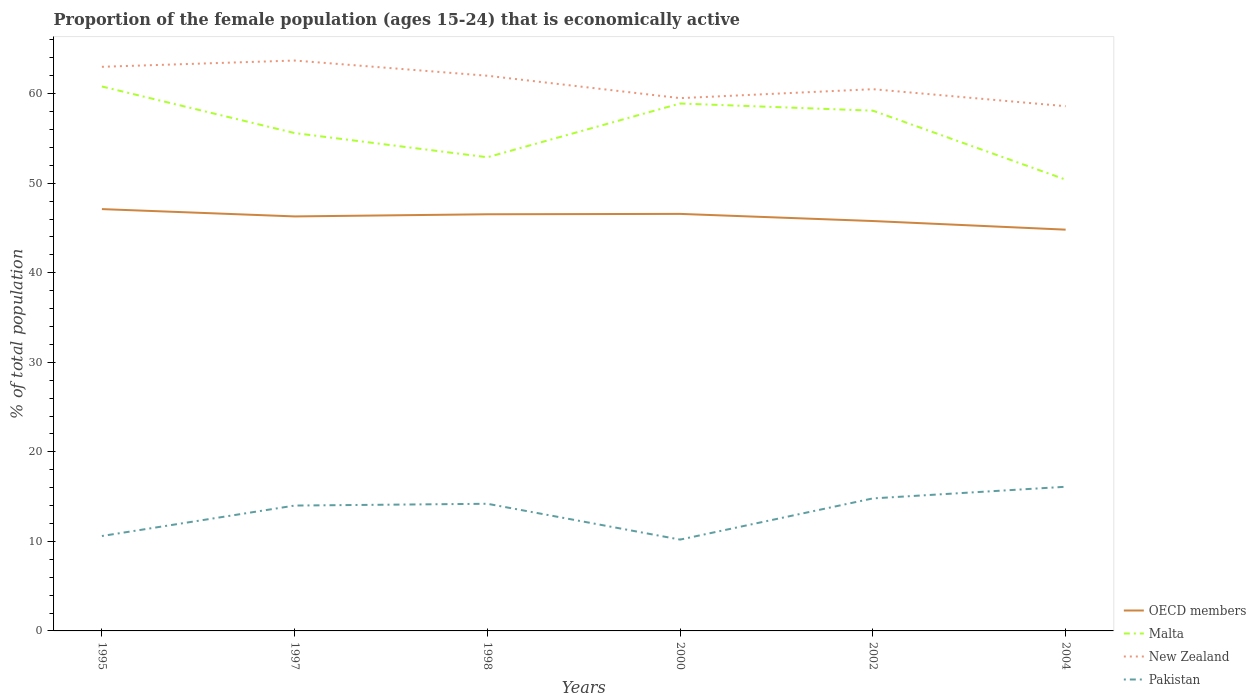Is the number of lines equal to the number of legend labels?
Offer a very short reply. Yes. Across all years, what is the maximum proportion of the female population that is economically active in Malta?
Your response must be concise. 50.4. In which year was the proportion of the female population that is economically active in OECD members maximum?
Your answer should be compact. 2004. What is the total proportion of the female population that is economically active in New Zealand in the graph?
Keep it short and to the point. 0.9. What is the difference between the highest and the second highest proportion of the female population that is economically active in OECD members?
Provide a succinct answer. 2.3. Is the proportion of the female population that is economically active in Malta strictly greater than the proportion of the female population that is economically active in OECD members over the years?
Your answer should be compact. No. How many lines are there?
Make the answer very short. 4. Are the values on the major ticks of Y-axis written in scientific E-notation?
Offer a very short reply. No. Does the graph contain any zero values?
Give a very brief answer. No. Where does the legend appear in the graph?
Keep it short and to the point. Bottom right. How many legend labels are there?
Give a very brief answer. 4. How are the legend labels stacked?
Your answer should be compact. Vertical. What is the title of the graph?
Make the answer very short. Proportion of the female population (ages 15-24) that is economically active. What is the label or title of the X-axis?
Offer a very short reply. Years. What is the label or title of the Y-axis?
Provide a short and direct response. % of total population. What is the % of total population in OECD members in 1995?
Your response must be concise. 47.11. What is the % of total population in Malta in 1995?
Your response must be concise. 60.8. What is the % of total population of Pakistan in 1995?
Give a very brief answer. 10.6. What is the % of total population in OECD members in 1997?
Give a very brief answer. 46.29. What is the % of total population in Malta in 1997?
Offer a very short reply. 55.6. What is the % of total population in New Zealand in 1997?
Keep it short and to the point. 63.7. What is the % of total population in Pakistan in 1997?
Make the answer very short. 14. What is the % of total population of OECD members in 1998?
Your answer should be very brief. 46.53. What is the % of total population of Malta in 1998?
Ensure brevity in your answer.  52.9. What is the % of total population in Pakistan in 1998?
Offer a very short reply. 14.2. What is the % of total population in OECD members in 2000?
Give a very brief answer. 46.57. What is the % of total population in Malta in 2000?
Offer a terse response. 58.9. What is the % of total population of New Zealand in 2000?
Your answer should be very brief. 59.5. What is the % of total population of Pakistan in 2000?
Offer a terse response. 10.2. What is the % of total population in OECD members in 2002?
Provide a succinct answer. 45.77. What is the % of total population in Malta in 2002?
Ensure brevity in your answer.  58.1. What is the % of total population of New Zealand in 2002?
Your answer should be compact. 60.5. What is the % of total population of Pakistan in 2002?
Make the answer very short. 14.8. What is the % of total population in OECD members in 2004?
Keep it short and to the point. 44.81. What is the % of total population in Malta in 2004?
Your response must be concise. 50.4. What is the % of total population in New Zealand in 2004?
Offer a very short reply. 58.6. What is the % of total population of Pakistan in 2004?
Make the answer very short. 16.1. Across all years, what is the maximum % of total population in OECD members?
Offer a terse response. 47.11. Across all years, what is the maximum % of total population in Malta?
Give a very brief answer. 60.8. Across all years, what is the maximum % of total population in New Zealand?
Make the answer very short. 63.7. Across all years, what is the maximum % of total population in Pakistan?
Provide a short and direct response. 16.1. Across all years, what is the minimum % of total population of OECD members?
Keep it short and to the point. 44.81. Across all years, what is the minimum % of total population in Malta?
Give a very brief answer. 50.4. Across all years, what is the minimum % of total population of New Zealand?
Provide a short and direct response. 58.6. Across all years, what is the minimum % of total population of Pakistan?
Provide a succinct answer. 10.2. What is the total % of total population in OECD members in the graph?
Offer a very short reply. 277.09. What is the total % of total population of Malta in the graph?
Make the answer very short. 336.7. What is the total % of total population in New Zealand in the graph?
Your answer should be very brief. 367.3. What is the total % of total population in Pakistan in the graph?
Provide a short and direct response. 79.9. What is the difference between the % of total population of OECD members in 1995 and that in 1997?
Give a very brief answer. 0.82. What is the difference between the % of total population of Malta in 1995 and that in 1997?
Ensure brevity in your answer.  5.2. What is the difference between the % of total population of OECD members in 1995 and that in 1998?
Your response must be concise. 0.58. What is the difference between the % of total population of Malta in 1995 and that in 1998?
Offer a terse response. 7.9. What is the difference between the % of total population in New Zealand in 1995 and that in 1998?
Ensure brevity in your answer.  1. What is the difference between the % of total population in OECD members in 1995 and that in 2000?
Your answer should be compact. 0.53. What is the difference between the % of total population of New Zealand in 1995 and that in 2000?
Your response must be concise. 3.5. What is the difference between the % of total population of Pakistan in 1995 and that in 2000?
Ensure brevity in your answer.  0.4. What is the difference between the % of total population of OECD members in 1995 and that in 2002?
Offer a very short reply. 1.33. What is the difference between the % of total population in OECD members in 1995 and that in 2004?
Ensure brevity in your answer.  2.3. What is the difference between the % of total population in Malta in 1995 and that in 2004?
Provide a short and direct response. 10.4. What is the difference between the % of total population of OECD members in 1997 and that in 1998?
Make the answer very short. -0.24. What is the difference between the % of total population in Malta in 1997 and that in 1998?
Ensure brevity in your answer.  2.7. What is the difference between the % of total population of Pakistan in 1997 and that in 1998?
Keep it short and to the point. -0.2. What is the difference between the % of total population of OECD members in 1997 and that in 2000?
Offer a very short reply. -0.28. What is the difference between the % of total population of OECD members in 1997 and that in 2002?
Give a very brief answer. 0.51. What is the difference between the % of total population in Malta in 1997 and that in 2002?
Provide a succinct answer. -2.5. What is the difference between the % of total population in OECD members in 1997 and that in 2004?
Provide a short and direct response. 1.48. What is the difference between the % of total population of Pakistan in 1997 and that in 2004?
Your response must be concise. -2.1. What is the difference between the % of total population of OECD members in 1998 and that in 2000?
Give a very brief answer. -0.04. What is the difference between the % of total population in New Zealand in 1998 and that in 2000?
Provide a short and direct response. 2.5. What is the difference between the % of total population of OECD members in 1998 and that in 2002?
Keep it short and to the point. 0.76. What is the difference between the % of total population of Malta in 1998 and that in 2002?
Keep it short and to the point. -5.2. What is the difference between the % of total population of New Zealand in 1998 and that in 2002?
Provide a succinct answer. 1.5. What is the difference between the % of total population of Pakistan in 1998 and that in 2002?
Provide a succinct answer. -0.6. What is the difference between the % of total population of OECD members in 1998 and that in 2004?
Your answer should be compact. 1.72. What is the difference between the % of total population of Malta in 1998 and that in 2004?
Provide a succinct answer. 2.5. What is the difference between the % of total population of New Zealand in 1998 and that in 2004?
Your answer should be very brief. 3.4. What is the difference between the % of total population of OECD members in 2000 and that in 2002?
Give a very brief answer. 0.8. What is the difference between the % of total population of Malta in 2000 and that in 2002?
Provide a succinct answer. 0.8. What is the difference between the % of total population in New Zealand in 2000 and that in 2002?
Offer a very short reply. -1. What is the difference between the % of total population of Pakistan in 2000 and that in 2002?
Your answer should be compact. -4.6. What is the difference between the % of total population in OECD members in 2000 and that in 2004?
Provide a succinct answer. 1.76. What is the difference between the % of total population in Pakistan in 2000 and that in 2004?
Provide a succinct answer. -5.9. What is the difference between the % of total population in OECD members in 2002 and that in 2004?
Provide a succinct answer. 0.96. What is the difference between the % of total population in Malta in 2002 and that in 2004?
Your answer should be very brief. 7.7. What is the difference between the % of total population of Pakistan in 2002 and that in 2004?
Keep it short and to the point. -1.3. What is the difference between the % of total population in OECD members in 1995 and the % of total population in Malta in 1997?
Provide a succinct answer. -8.49. What is the difference between the % of total population of OECD members in 1995 and the % of total population of New Zealand in 1997?
Offer a very short reply. -16.59. What is the difference between the % of total population of OECD members in 1995 and the % of total population of Pakistan in 1997?
Your answer should be very brief. 33.11. What is the difference between the % of total population in Malta in 1995 and the % of total population in New Zealand in 1997?
Offer a terse response. -2.9. What is the difference between the % of total population of Malta in 1995 and the % of total population of Pakistan in 1997?
Your answer should be compact. 46.8. What is the difference between the % of total population of OECD members in 1995 and the % of total population of Malta in 1998?
Offer a terse response. -5.79. What is the difference between the % of total population in OECD members in 1995 and the % of total population in New Zealand in 1998?
Offer a very short reply. -14.89. What is the difference between the % of total population of OECD members in 1995 and the % of total population of Pakistan in 1998?
Your answer should be compact. 32.91. What is the difference between the % of total population of Malta in 1995 and the % of total population of Pakistan in 1998?
Offer a very short reply. 46.6. What is the difference between the % of total population of New Zealand in 1995 and the % of total population of Pakistan in 1998?
Your answer should be compact. 48.8. What is the difference between the % of total population in OECD members in 1995 and the % of total population in Malta in 2000?
Provide a short and direct response. -11.79. What is the difference between the % of total population in OECD members in 1995 and the % of total population in New Zealand in 2000?
Ensure brevity in your answer.  -12.39. What is the difference between the % of total population of OECD members in 1995 and the % of total population of Pakistan in 2000?
Provide a succinct answer. 36.91. What is the difference between the % of total population of Malta in 1995 and the % of total population of Pakistan in 2000?
Keep it short and to the point. 50.6. What is the difference between the % of total population in New Zealand in 1995 and the % of total population in Pakistan in 2000?
Provide a succinct answer. 52.8. What is the difference between the % of total population in OECD members in 1995 and the % of total population in Malta in 2002?
Provide a short and direct response. -10.99. What is the difference between the % of total population of OECD members in 1995 and the % of total population of New Zealand in 2002?
Give a very brief answer. -13.39. What is the difference between the % of total population in OECD members in 1995 and the % of total population in Pakistan in 2002?
Give a very brief answer. 32.31. What is the difference between the % of total population in Malta in 1995 and the % of total population in New Zealand in 2002?
Offer a terse response. 0.3. What is the difference between the % of total population in New Zealand in 1995 and the % of total population in Pakistan in 2002?
Make the answer very short. 48.2. What is the difference between the % of total population of OECD members in 1995 and the % of total population of Malta in 2004?
Ensure brevity in your answer.  -3.29. What is the difference between the % of total population in OECD members in 1995 and the % of total population in New Zealand in 2004?
Your answer should be very brief. -11.49. What is the difference between the % of total population in OECD members in 1995 and the % of total population in Pakistan in 2004?
Make the answer very short. 31.01. What is the difference between the % of total population in Malta in 1995 and the % of total population in New Zealand in 2004?
Ensure brevity in your answer.  2.2. What is the difference between the % of total population of Malta in 1995 and the % of total population of Pakistan in 2004?
Your answer should be compact. 44.7. What is the difference between the % of total population in New Zealand in 1995 and the % of total population in Pakistan in 2004?
Your response must be concise. 46.9. What is the difference between the % of total population in OECD members in 1997 and the % of total population in Malta in 1998?
Ensure brevity in your answer.  -6.61. What is the difference between the % of total population in OECD members in 1997 and the % of total population in New Zealand in 1998?
Offer a very short reply. -15.71. What is the difference between the % of total population of OECD members in 1997 and the % of total population of Pakistan in 1998?
Keep it short and to the point. 32.09. What is the difference between the % of total population in Malta in 1997 and the % of total population in Pakistan in 1998?
Make the answer very short. 41.4. What is the difference between the % of total population in New Zealand in 1997 and the % of total population in Pakistan in 1998?
Offer a terse response. 49.5. What is the difference between the % of total population in OECD members in 1997 and the % of total population in Malta in 2000?
Ensure brevity in your answer.  -12.61. What is the difference between the % of total population of OECD members in 1997 and the % of total population of New Zealand in 2000?
Your response must be concise. -13.21. What is the difference between the % of total population in OECD members in 1997 and the % of total population in Pakistan in 2000?
Your answer should be very brief. 36.09. What is the difference between the % of total population of Malta in 1997 and the % of total population of Pakistan in 2000?
Provide a short and direct response. 45.4. What is the difference between the % of total population in New Zealand in 1997 and the % of total population in Pakistan in 2000?
Provide a succinct answer. 53.5. What is the difference between the % of total population in OECD members in 1997 and the % of total population in Malta in 2002?
Provide a succinct answer. -11.81. What is the difference between the % of total population in OECD members in 1997 and the % of total population in New Zealand in 2002?
Your response must be concise. -14.21. What is the difference between the % of total population in OECD members in 1997 and the % of total population in Pakistan in 2002?
Offer a very short reply. 31.49. What is the difference between the % of total population of Malta in 1997 and the % of total population of Pakistan in 2002?
Offer a terse response. 40.8. What is the difference between the % of total population of New Zealand in 1997 and the % of total population of Pakistan in 2002?
Provide a short and direct response. 48.9. What is the difference between the % of total population in OECD members in 1997 and the % of total population in Malta in 2004?
Offer a terse response. -4.11. What is the difference between the % of total population in OECD members in 1997 and the % of total population in New Zealand in 2004?
Offer a very short reply. -12.31. What is the difference between the % of total population in OECD members in 1997 and the % of total population in Pakistan in 2004?
Give a very brief answer. 30.19. What is the difference between the % of total population of Malta in 1997 and the % of total population of Pakistan in 2004?
Your answer should be compact. 39.5. What is the difference between the % of total population of New Zealand in 1997 and the % of total population of Pakistan in 2004?
Offer a terse response. 47.6. What is the difference between the % of total population of OECD members in 1998 and the % of total population of Malta in 2000?
Your answer should be compact. -12.37. What is the difference between the % of total population in OECD members in 1998 and the % of total population in New Zealand in 2000?
Your response must be concise. -12.97. What is the difference between the % of total population of OECD members in 1998 and the % of total population of Pakistan in 2000?
Ensure brevity in your answer.  36.33. What is the difference between the % of total population of Malta in 1998 and the % of total population of New Zealand in 2000?
Ensure brevity in your answer.  -6.6. What is the difference between the % of total population in Malta in 1998 and the % of total population in Pakistan in 2000?
Provide a succinct answer. 42.7. What is the difference between the % of total population in New Zealand in 1998 and the % of total population in Pakistan in 2000?
Provide a succinct answer. 51.8. What is the difference between the % of total population of OECD members in 1998 and the % of total population of Malta in 2002?
Make the answer very short. -11.57. What is the difference between the % of total population in OECD members in 1998 and the % of total population in New Zealand in 2002?
Provide a succinct answer. -13.97. What is the difference between the % of total population of OECD members in 1998 and the % of total population of Pakistan in 2002?
Your answer should be compact. 31.73. What is the difference between the % of total population in Malta in 1998 and the % of total population in Pakistan in 2002?
Provide a short and direct response. 38.1. What is the difference between the % of total population in New Zealand in 1998 and the % of total population in Pakistan in 2002?
Make the answer very short. 47.2. What is the difference between the % of total population of OECD members in 1998 and the % of total population of Malta in 2004?
Ensure brevity in your answer.  -3.87. What is the difference between the % of total population of OECD members in 1998 and the % of total population of New Zealand in 2004?
Offer a very short reply. -12.07. What is the difference between the % of total population in OECD members in 1998 and the % of total population in Pakistan in 2004?
Keep it short and to the point. 30.43. What is the difference between the % of total population in Malta in 1998 and the % of total population in Pakistan in 2004?
Provide a short and direct response. 36.8. What is the difference between the % of total population in New Zealand in 1998 and the % of total population in Pakistan in 2004?
Your answer should be very brief. 45.9. What is the difference between the % of total population in OECD members in 2000 and the % of total population in Malta in 2002?
Keep it short and to the point. -11.53. What is the difference between the % of total population in OECD members in 2000 and the % of total population in New Zealand in 2002?
Make the answer very short. -13.93. What is the difference between the % of total population in OECD members in 2000 and the % of total population in Pakistan in 2002?
Ensure brevity in your answer.  31.77. What is the difference between the % of total population of Malta in 2000 and the % of total population of Pakistan in 2002?
Keep it short and to the point. 44.1. What is the difference between the % of total population in New Zealand in 2000 and the % of total population in Pakistan in 2002?
Give a very brief answer. 44.7. What is the difference between the % of total population of OECD members in 2000 and the % of total population of Malta in 2004?
Offer a very short reply. -3.83. What is the difference between the % of total population of OECD members in 2000 and the % of total population of New Zealand in 2004?
Your answer should be compact. -12.03. What is the difference between the % of total population in OECD members in 2000 and the % of total population in Pakistan in 2004?
Offer a very short reply. 30.47. What is the difference between the % of total population of Malta in 2000 and the % of total population of Pakistan in 2004?
Your answer should be compact. 42.8. What is the difference between the % of total population in New Zealand in 2000 and the % of total population in Pakistan in 2004?
Offer a terse response. 43.4. What is the difference between the % of total population in OECD members in 2002 and the % of total population in Malta in 2004?
Offer a very short reply. -4.63. What is the difference between the % of total population in OECD members in 2002 and the % of total population in New Zealand in 2004?
Offer a terse response. -12.83. What is the difference between the % of total population of OECD members in 2002 and the % of total population of Pakistan in 2004?
Ensure brevity in your answer.  29.67. What is the difference between the % of total population in Malta in 2002 and the % of total population in Pakistan in 2004?
Your answer should be very brief. 42. What is the difference between the % of total population in New Zealand in 2002 and the % of total population in Pakistan in 2004?
Offer a very short reply. 44.4. What is the average % of total population of OECD members per year?
Offer a very short reply. 46.18. What is the average % of total population of Malta per year?
Make the answer very short. 56.12. What is the average % of total population in New Zealand per year?
Provide a succinct answer. 61.22. What is the average % of total population in Pakistan per year?
Provide a succinct answer. 13.32. In the year 1995, what is the difference between the % of total population of OECD members and % of total population of Malta?
Your answer should be compact. -13.69. In the year 1995, what is the difference between the % of total population of OECD members and % of total population of New Zealand?
Provide a succinct answer. -15.89. In the year 1995, what is the difference between the % of total population of OECD members and % of total population of Pakistan?
Your response must be concise. 36.51. In the year 1995, what is the difference between the % of total population in Malta and % of total population in Pakistan?
Your answer should be very brief. 50.2. In the year 1995, what is the difference between the % of total population in New Zealand and % of total population in Pakistan?
Your answer should be compact. 52.4. In the year 1997, what is the difference between the % of total population in OECD members and % of total population in Malta?
Keep it short and to the point. -9.31. In the year 1997, what is the difference between the % of total population in OECD members and % of total population in New Zealand?
Ensure brevity in your answer.  -17.41. In the year 1997, what is the difference between the % of total population in OECD members and % of total population in Pakistan?
Keep it short and to the point. 32.29. In the year 1997, what is the difference between the % of total population in Malta and % of total population in Pakistan?
Keep it short and to the point. 41.6. In the year 1997, what is the difference between the % of total population in New Zealand and % of total population in Pakistan?
Your answer should be very brief. 49.7. In the year 1998, what is the difference between the % of total population of OECD members and % of total population of Malta?
Provide a succinct answer. -6.37. In the year 1998, what is the difference between the % of total population of OECD members and % of total population of New Zealand?
Provide a succinct answer. -15.47. In the year 1998, what is the difference between the % of total population in OECD members and % of total population in Pakistan?
Your answer should be compact. 32.33. In the year 1998, what is the difference between the % of total population of Malta and % of total population of Pakistan?
Your response must be concise. 38.7. In the year 1998, what is the difference between the % of total population in New Zealand and % of total population in Pakistan?
Your response must be concise. 47.8. In the year 2000, what is the difference between the % of total population in OECD members and % of total population in Malta?
Provide a succinct answer. -12.33. In the year 2000, what is the difference between the % of total population of OECD members and % of total population of New Zealand?
Offer a terse response. -12.93. In the year 2000, what is the difference between the % of total population of OECD members and % of total population of Pakistan?
Your answer should be compact. 36.37. In the year 2000, what is the difference between the % of total population of Malta and % of total population of Pakistan?
Provide a short and direct response. 48.7. In the year 2000, what is the difference between the % of total population of New Zealand and % of total population of Pakistan?
Offer a very short reply. 49.3. In the year 2002, what is the difference between the % of total population in OECD members and % of total population in Malta?
Offer a terse response. -12.33. In the year 2002, what is the difference between the % of total population of OECD members and % of total population of New Zealand?
Make the answer very short. -14.73. In the year 2002, what is the difference between the % of total population in OECD members and % of total population in Pakistan?
Offer a terse response. 30.97. In the year 2002, what is the difference between the % of total population of Malta and % of total population of Pakistan?
Make the answer very short. 43.3. In the year 2002, what is the difference between the % of total population of New Zealand and % of total population of Pakistan?
Your answer should be very brief. 45.7. In the year 2004, what is the difference between the % of total population in OECD members and % of total population in Malta?
Your response must be concise. -5.59. In the year 2004, what is the difference between the % of total population of OECD members and % of total population of New Zealand?
Offer a terse response. -13.79. In the year 2004, what is the difference between the % of total population in OECD members and % of total population in Pakistan?
Your answer should be very brief. 28.71. In the year 2004, what is the difference between the % of total population in Malta and % of total population in New Zealand?
Offer a very short reply. -8.2. In the year 2004, what is the difference between the % of total population in Malta and % of total population in Pakistan?
Your answer should be very brief. 34.3. In the year 2004, what is the difference between the % of total population of New Zealand and % of total population of Pakistan?
Provide a succinct answer. 42.5. What is the ratio of the % of total population of OECD members in 1995 to that in 1997?
Your answer should be very brief. 1.02. What is the ratio of the % of total population in Malta in 1995 to that in 1997?
Provide a short and direct response. 1.09. What is the ratio of the % of total population in Pakistan in 1995 to that in 1997?
Give a very brief answer. 0.76. What is the ratio of the % of total population in OECD members in 1995 to that in 1998?
Offer a terse response. 1.01. What is the ratio of the % of total population in Malta in 1995 to that in 1998?
Make the answer very short. 1.15. What is the ratio of the % of total population of New Zealand in 1995 to that in 1998?
Offer a terse response. 1.02. What is the ratio of the % of total population in Pakistan in 1995 to that in 1998?
Provide a succinct answer. 0.75. What is the ratio of the % of total population of OECD members in 1995 to that in 2000?
Make the answer very short. 1.01. What is the ratio of the % of total population in Malta in 1995 to that in 2000?
Offer a terse response. 1.03. What is the ratio of the % of total population in New Zealand in 1995 to that in 2000?
Give a very brief answer. 1.06. What is the ratio of the % of total population of Pakistan in 1995 to that in 2000?
Offer a terse response. 1.04. What is the ratio of the % of total population of OECD members in 1995 to that in 2002?
Your answer should be compact. 1.03. What is the ratio of the % of total population in Malta in 1995 to that in 2002?
Offer a terse response. 1.05. What is the ratio of the % of total population in New Zealand in 1995 to that in 2002?
Your answer should be very brief. 1.04. What is the ratio of the % of total population in Pakistan in 1995 to that in 2002?
Ensure brevity in your answer.  0.72. What is the ratio of the % of total population in OECD members in 1995 to that in 2004?
Make the answer very short. 1.05. What is the ratio of the % of total population in Malta in 1995 to that in 2004?
Your answer should be compact. 1.21. What is the ratio of the % of total population of New Zealand in 1995 to that in 2004?
Provide a succinct answer. 1.08. What is the ratio of the % of total population in Pakistan in 1995 to that in 2004?
Provide a succinct answer. 0.66. What is the ratio of the % of total population of Malta in 1997 to that in 1998?
Your answer should be very brief. 1.05. What is the ratio of the % of total population of New Zealand in 1997 to that in 1998?
Offer a very short reply. 1.03. What is the ratio of the % of total population in Pakistan in 1997 to that in 1998?
Ensure brevity in your answer.  0.99. What is the ratio of the % of total population in OECD members in 1997 to that in 2000?
Ensure brevity in your answer.  0.99. What is the ratio of the % of total population in Malta in 1997 to that in 2000?
Your answer should be very brief. 0.94. What is the ratio of the % of total population of New Zealand in 1997 to that in 2000?
Your response must be concise. 1.07. What is the ratio of the % of total population in Pakistan in 1997 to that in 2000?
Offer a terse response. 1.37. What is the ratio of the % of total population of OECD members in 1997 to that in 2002?
Provide a short and direct response. 1.01. What is the ratio of the % of total population of New Zealand in 1997 to that in 2002?
Keep it short and to the point. 1.05. What is the ratio of the % of total population of Pakistan in 1997 to that in 2002?
Offer a terse response. 0.95. What is the ratio of the % of total population in OECD members in 1997 to that in 2004?
Offer a very short reply. 1.03. What is the ratio of the % of total population in Malta in 1997 to that in 2004?
Provide a short and direct response. 1.1. What is the ratio of the % of total population in New Zealand in 1997 to that in 2004?
Provide a succinct answer. 1.09. What is the ratio of the % of total population in Pakistan in 1997 to that in 2004?
Your answer should be very brief. 0.87. What is the ratio of the % of total population in OECD members in 1998 to that in 2000?
Your answer should be very brief. 1. What is the ratio of the % of total population of Malta in 1998 to that in 2000?
Make the answer very short. 0.9. What is the ratio of the % of total population in New Zealand in 1998 to that in 2000?
Give a very brief answer. 1.04. What is the ratio of the % of total population of Pakistan in 1998 to that in 2000?
Make the answer very short. 1.39. What is the ratio of the % of total population in OECD members in 1998 to that in 2002?
Make the answer very short. 1.02. What is the ratio of the % of total population of Malta in 1998 to that in 2002?
Provide a succinct answer. 0.91. What is the ratio of the % of total population in New Zealand in 1998 to that in 2002?
Offer a very short reply. 1.02. What is the ratio of the % of total population of Pakistan in 1998 to that in 2002?
Your response must be concise. 0.96. What is the ratio of the % of total population of OECD members in 1998 to that in 2004?
Your answer should be very brief. 1.04. What is the ratio of the % of total population in Malta in 1998 to that in 2004?
Make the answer very short. 1.05. What is the ratio of the % of total population in New Zealand in 1998 to that in 2004?
Give a very brief answer. 1.06. What is the ratio of the % of total population of Pakistan in 1998 to that in 2004?
Your answer should be very brief. 0.88. What is the ratio of the % of total population in OECD members in 2000 to that in 2002?
Ensure brevity in your answer.  1.02. What is the ratio of the % of total population of Malta in 2000 to that in 2002?
Ensure brevity in your answer.  1.01. What is the ratio of the % of total population of New Zealand in 2000 to that in 2002?
Your answer should be compact. 0.98. What is the ratio of the % of total population in Pakistan in 2000 to that in 2002?
Your answer should be very brief. 0.69. What is the ratio of the % of total population in OECD members in 2000 to that in 2004?
Your answer should be very brief. 1.04. What is the ratio of the % of total population of Malta in 2000 to that in 2004?
Offer a very short reply. 1.17. What is the ratio of the % of total population in New Zealand in 2000 to that in 2004?
Make the answer very short. 1.02. What is the ratio of the % of total population of Pakistan in 2000 to that in 2004?
Give a very brief answer. 0.63. What is the ratio of the % of total population in OECD members in 2002 to that in 2004?
Offer a terse response. 1.02. What is the ratio of the % of total population in Malta in 2002 to that in 2004?
Provide a succinct answer. 1.15. What is the ratio of the % of total population in New Zealand in 2002 to that in 2004?
Provide a short and direct response. 1.03. What is the ratio of the % of total population of Pakistan in 2002 to that in 2004?
Ensure brevity in your answer.  0.92. What is the difference between the highest and the second highest % of total population in OECD members?
Ensure brevity in your answer.  0.53. What is the difference between the highest and the second highest % of total population of Malta?
Ensure brevity in your answer.  1.9. What is the difference between the highest and the lowest % of total population of OECD members?
Offer a very short reply. 2.3. What is the difference between the highest and the lowest % of total population in Malta?
Provide a short and direct response. 10.4. What is the difference between the highest and the lowest % of total population in Pakistan?
Keep it short and to the point. 5.9. 